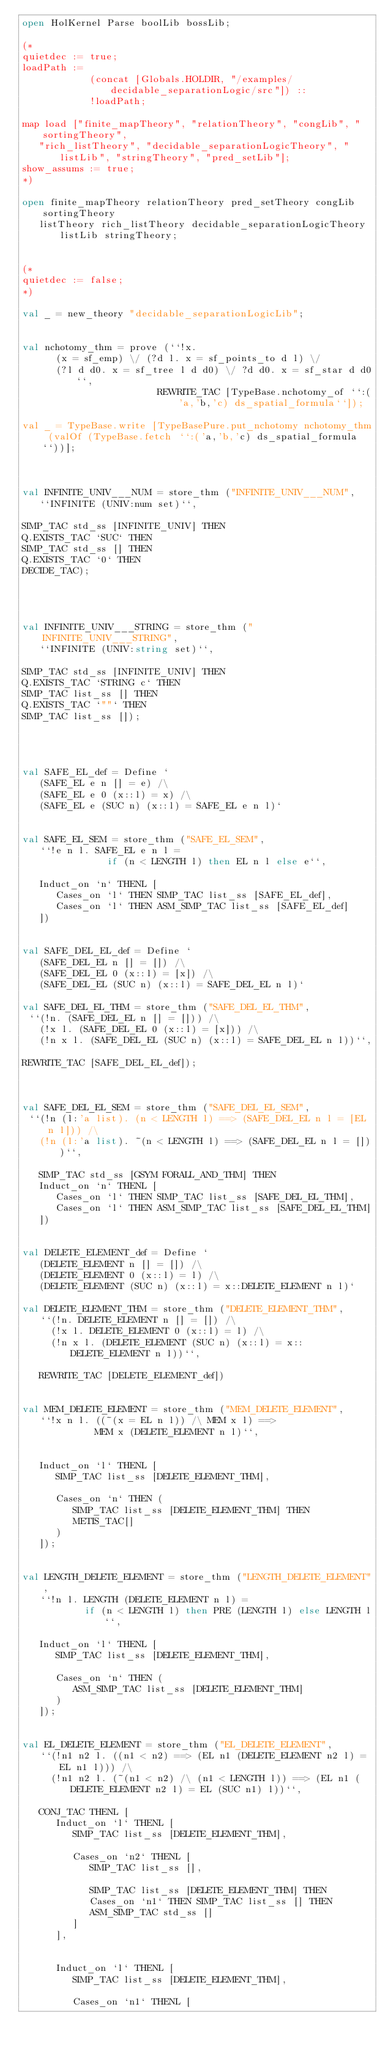<code> <loc_0><loc_0><loc_500><loc_500><_SML_>open HolKernel Parse boolLib bossLib;

(*
quietdec := true;
loadPath :=
            (concat [Globals.HOLDIR, "/examples/decidable_separationLogic/src"]) ::
            !loadPath;

map load ["finite_mapTheory", "relationTheory", "congLib", "sortingTheory",
   "rich_listTheory", "decidable_separationLogicTheory", "listLib", "stringTheory", "pred_setLib"];
show_assums := true;
*)

open finite_mapTheory relationTheory pred_setTheory congLib sortingTheory
   listTheory rich_listTheory decidable_separationLogicTheory listLib stringTheory;


(*
quietdec := false;
*)

val _ = new_theory "decidable_separationLogicLib";


val nchotomy_thm = prove (``!x.
      (x = sf_emp) \/ (?d l. x = sf_points_to d l) \/
      (?l d d0. x = sf_tree l d d0) \/ ?d d0. x = sf_star d d0``,
                        REWRITE_TAC [TypeBase.nchotomy_of ``:('a,'b,'c) ds_spatial_formula``]);

val _ = TypeBase.write [TypeBasePure.put_nchotomy nchotomy_thm (valOf (TypeBase.fetch ``:('a,'b,'c) ds_spatial_formula``))];



val INFINITE_UNIV___NUM = store_thm ("INFINITE_UNIV___NUM",
   ``INFINITE (UNIV:num set)``,

SIMP_TAC std_ss [INFINITE_UNIV] THEN
Q.EXISTS_TAC `SUC` THEN
SIMP_TAC std_ss [] THEN
Q.EXISTS_TAC `0` THEN
DECIDE_TAC);




val INFINITE_UNIV___STRING = store_thm ("INFINITE_UNIV___STRING",
   ``INFINITE (UNIV:string set)``,

SIMP_TAC std_ss [INFINITE_UNIV] THEN
Q.EXISTS_TAC `STRING c` THEN
SIMP_TAC list_ss [] THEN
Q.EXISTS_TAC `""` THEN
SIMP_TAC list_ss []);




val SAFE_EL_def = Define `
   (SAFE_EL e n [] = e) /\
   (SAFE_EL e 0 (x::l) = x) /\
   (SAFE_EL e (SUC n) (x::l) = SAFE_EL e n l)`


val SAFE_EL_SEM = store_thm ("SAFE_EL_SEM",
   ``!e n l. SAFE_EL e n l =
               if (n < LENGTH l) then EL n l else e``,

   Induct_on `n` THENL [
      Cases_on `l` THEN SIMP_TAC list_ss [SAFE_EL_def],
      Cases_on `l` THEN ASM_SIMP_TAC list_ss [SAFE_EL_def]
   ])


val SAFE_DEL_EL_def = Define `
   (SAFE_DEL_EL n [] = []) /\
   (SAFE_DEL_EL 0 (x::l) = [x]) /\
   (SAFE_DEL_EL (SUC n) (x::l) = SAFE_DEL_EL n l)`

val SAFE_DEL_EL_THM = store_thm ("SAFE_DEL_EL_THM",
 ``(!n. (SAFE_DEL_EL n [] = [])) /\
   (!x l. (SAFE_DEL_EL 0 (x::l) = [x])) /\
   (!n x l. (SAFE_DEL_EL (SUC n) (x::l) = SAFE_DEL_EL n l))``,

REWRITE_TAC [SAFE_DEL_EL_def]);



val SAFE_DEL_EL_SEM = store_thm ("SAFE_DEL_EL_SEM",
 ``(!n (l:'a list). (n < LENGTH l) ==> (SAFE_DEL_EL n l = [EL n l])) /\
   (!n (l:'a list). ~(n < LENGTH l) ==> (SAFE_DEL_EL n l = []))``,

   SIMP_TAC std_ss [GSYM FORALL_AND_THM] THEN
   Induct_on `n` THENL [
      Cases_on `l` THEN SIMP_TAC list_ss [SAFE_DEL_EL_THM],
      Cases_on `l` THEN ASM_SIMP_TAC list_ss [SAFE_DEL_EL_THM]
   ])


val DELETE_ELEMENT_def = Define `
   (DELETE_ELEMENT n [] = []) /\
   (DELETE_ELEMENT 0 (x::l) = l) /\
   (DELETE_ELEMENT (SUC n) (x::l) = x::DELETE_ELEMENT n l)`

val DELETE_ELEMENT_THM = store_thm ("DELETE_ELEMENT_THM",
   ``(!n. DELETE_ELEMENT n [] = []) /\
     (!x l. DELETE_ELEMENT 0 (x::l) = l) /\
     (!n x l. (DELETE_ELEMENT (SUC n) (x::l) = x::DELETE_ELEMENT n l))``,

   REWRITE_TAC [DELETE_ELEMENT_def])


val MEM_DELETE_ELEMENT = store_thm ("MEM_DELETE_ELEMENT",
   ``!x n l. ((~(x = EL n l)) /\ MEM x l) ==>
             MEM x (DELETE_ELEMENT n l)``,


   Induct_on `l` THENL [
      SIMP_TAC list_ss [DELETE_ELEMENT_THM],

      Cases_on `n` THEN (
         SIMP_TAC list_ss [DELETE_ELEMENT_THM] THEN
         METIS_TAC[]
      )
   ]);


val LENGTH_DELETE_ELEMENT = store_thm ("LENGTH_DELETE_ELEMENT",
   ``!n l. LENGTH (DELETE_ELEMENT n l) =
           if (n < LENGTH l) then PRE (LENGTH l) else LENGTH l``,

   Induct_on `l` THENL [
      SIMP_TAC list_ss [DELETE_ELEMENT_THM],

      Cases_on `n` THEN (
         ASM_SIMP_TAC list_ss [DELETE_ELEMENT_THM]
      )
   ]);


val EL_DELETE_ELEMENT = store_thm ("EL_DELETE_ELEMENT",
   ``(!n1 n2 l. ((n1 < n2) ==> (EL n1 (DELETE_ELEMENT n2 l) = EL n1 l))) /\
     (!n1 n2 l. (~(n1 < n2) /\ (n1 < LENGTH l)) ==> (EL n1 (DELETE_ELEMENT n2 l) = EL (SUC n1) l))``,

   CONJ_TAC THENL [
      Induct_on `l` THENL [
         SIMP_TAC list_ss [DELETE_ELEMENT_THM],

         Cases_on `n2` THENL [
            SIMP_TAC list_ss [],

            SIMP_TAC list_ss [DELETE_ELEMENT_THM] THEN
            Cases_on `n1` THEN SIMP_TAC list_ss [] THEN
            ASM_SIMP_TAC std_ss []
         ]
      ],


      Induct_on `l` THENL [
         SIMP_TAC list_ss [DELETE_ELEMENT_THM],

         Cases_on `n1` THENL [</code> 